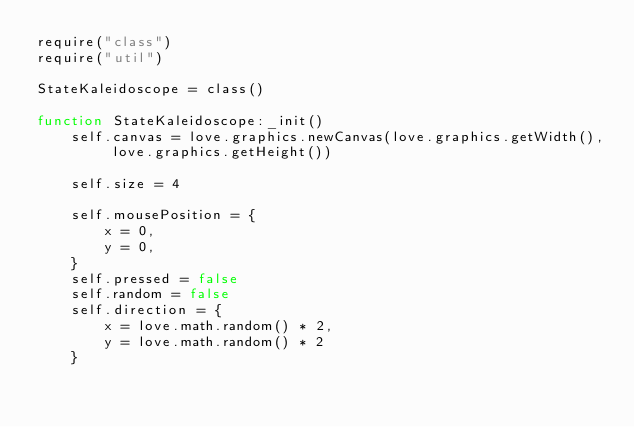Convert code to text. <code><loc_0><loc_0><loc_500><loc_500><_Lua_>require("class")
require("util")

StateKaleidoscope = class()

function StateKaleidoscope:_init()
	self.canvas = love.graphics.newCanvas(love.graphics.getWidth(), love.graphics.getHeight())

	self.size = 4

	self.mousePosition = {
		x = 0,
		y = 0,
	}
	self.pressed = false
	self.random = false
	self.direction = {
		x = love.math.random() * 2,
		y = love.math.random() * 2
	}
</code> 